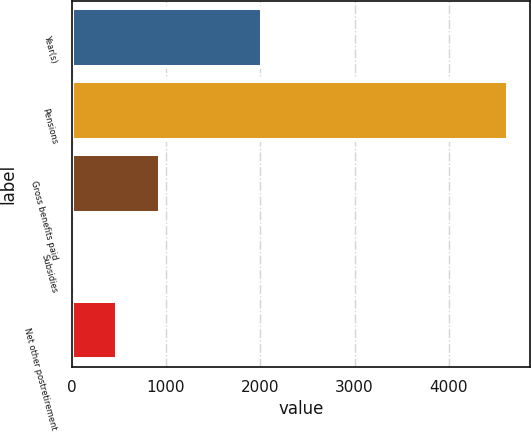Convert chart to OTSL. <chart><loc_0><loc_0><loc_500><loc_500><bar_chart><fcel>Year(s)<fcel>Pensions<fcel>Gross benefits paid<fcel>Subsidies<fcel>Net other postretirement<nl><fcel>2022<fcel>4630<fcel>940.4<fcel>18<fcel>479.2<nl></chart> 